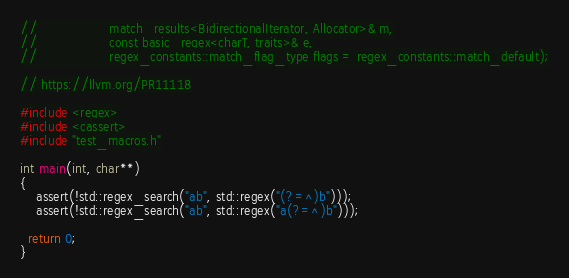Convert code to text. <code><loc_0><loc_0><loc_500><loc_500><_C++_>//                  match_results<BidirectionalIterator, Allocator>& m,
//                  const basic_regex<charT, traits>& e,
//                  regex_constants::match_flag_type flags = regex_constants::match_default);

// https://llvm.org/PR11118

#include <regex>
#include <cassert>
#include "test_macros.h"

int main(int, char**)
{
    assert(!std::regex_search("ab", std::regex("(?=^)b")));
    assert(!std::regex_search("ab", std::regex("a(?=^)b")));

  return 0;
}
</code> 